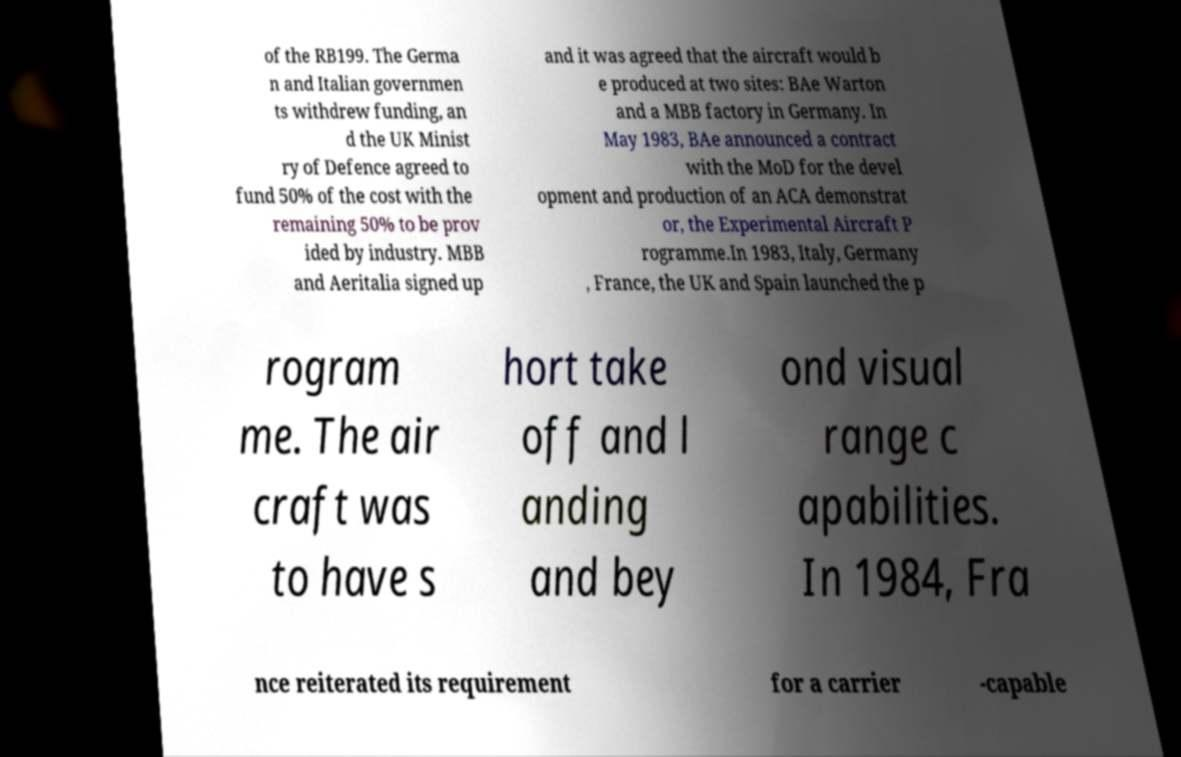I need the written content from this picture converted into text. Can you do that? of the RB199. The Germa n and Italian governmen ts withdrew funding, an d the UK Minist ry of Defence agreed to fund 50% of the cost with the remaining 50% to be prov ided by industry. MBB and Aeritalia signed up and it was agreed that the aircraft would b e produced at two sites: BAe Warton and a MBB factory in Germany. In May 1983, BAe announced a contract with the MoD for the devel opment and production of an ACA demonstrat or, the Experimental Aircraft P rogramme.In 1983, Italy, Germany , France, the UK and Spain launched the p rogram me. The air craft was to have s hort take off and l anding and bey ond visual range c apabilities. In 1984, Fra nce reiterated its requirement for a carrier -capable 